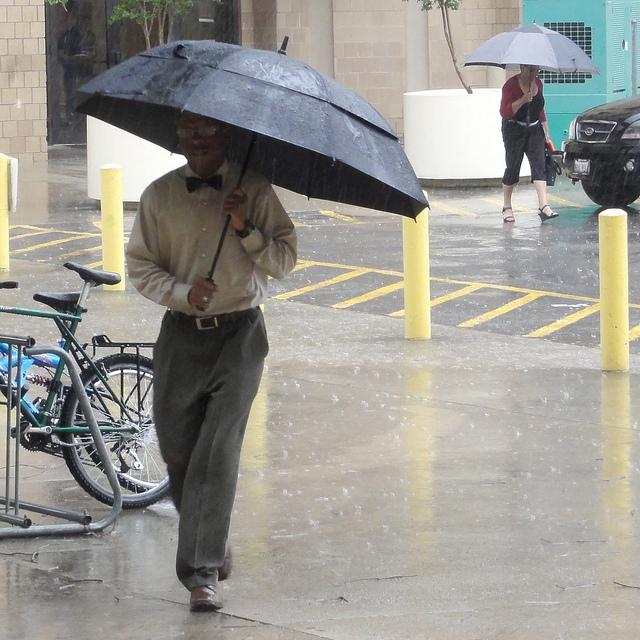What kind of tie is the man wearing?
Be succinct. Bow. How many umbrella are open?
Write a very short answer. 2. What number of bike racks are in this scene?
Write a very short answer. 1. How many umbrellas in the photo?
Concise answer only. 2. 